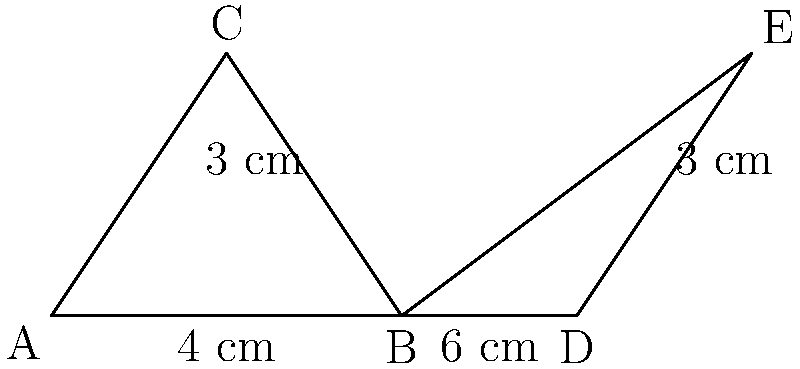In your freezer, you have two triangular storage containers represented by triangles ABC and BDE. If AB = 4 cm, BD = 6 cm, and both containers have a height of 3 cm, are these triangles congruent? If so, which congruence criterion proves this? To determine if triangles ABC and BDE are congruent, we need to examine their sides and angles:

1. Given information:
   - AB = 4 cm
   - BD = 6 cm
   - BC = DE = 3 cm (heights of both triangles)

2. Observe that B is a common vertex for both triangles.

3. In triangle ABC:
   - AB = 4 cm
   - BC = 3 cm
   - Angle B is shared with triangle BDE

4. In triangle BDE:
   - BD = 6 cm
   - DE = 3 cm
   - Angle B is shared with triangle ABC

5. To prove congruence, we need three corresponding parts to be equal. We have:
   - One pair of corresponding sides: BC = DE = 3 cm
   - A shared angle at vertex B

6. For the triangles to be congruent, we would need one more pair of corresponding parts to be equal. However, AB ≠ BD (4 cm ≠ 6 cm).

7. Since we don't have enough corresponding parts that are equal, we cannot conclude that these triangles are congruent.

8. The SAS (Side-Angle-Side) criterion would have been applicable if AB = BD, but this is not the case here.

Therefore, triangles ABC and BDE are not congruent.
Answer: No, not congruent 